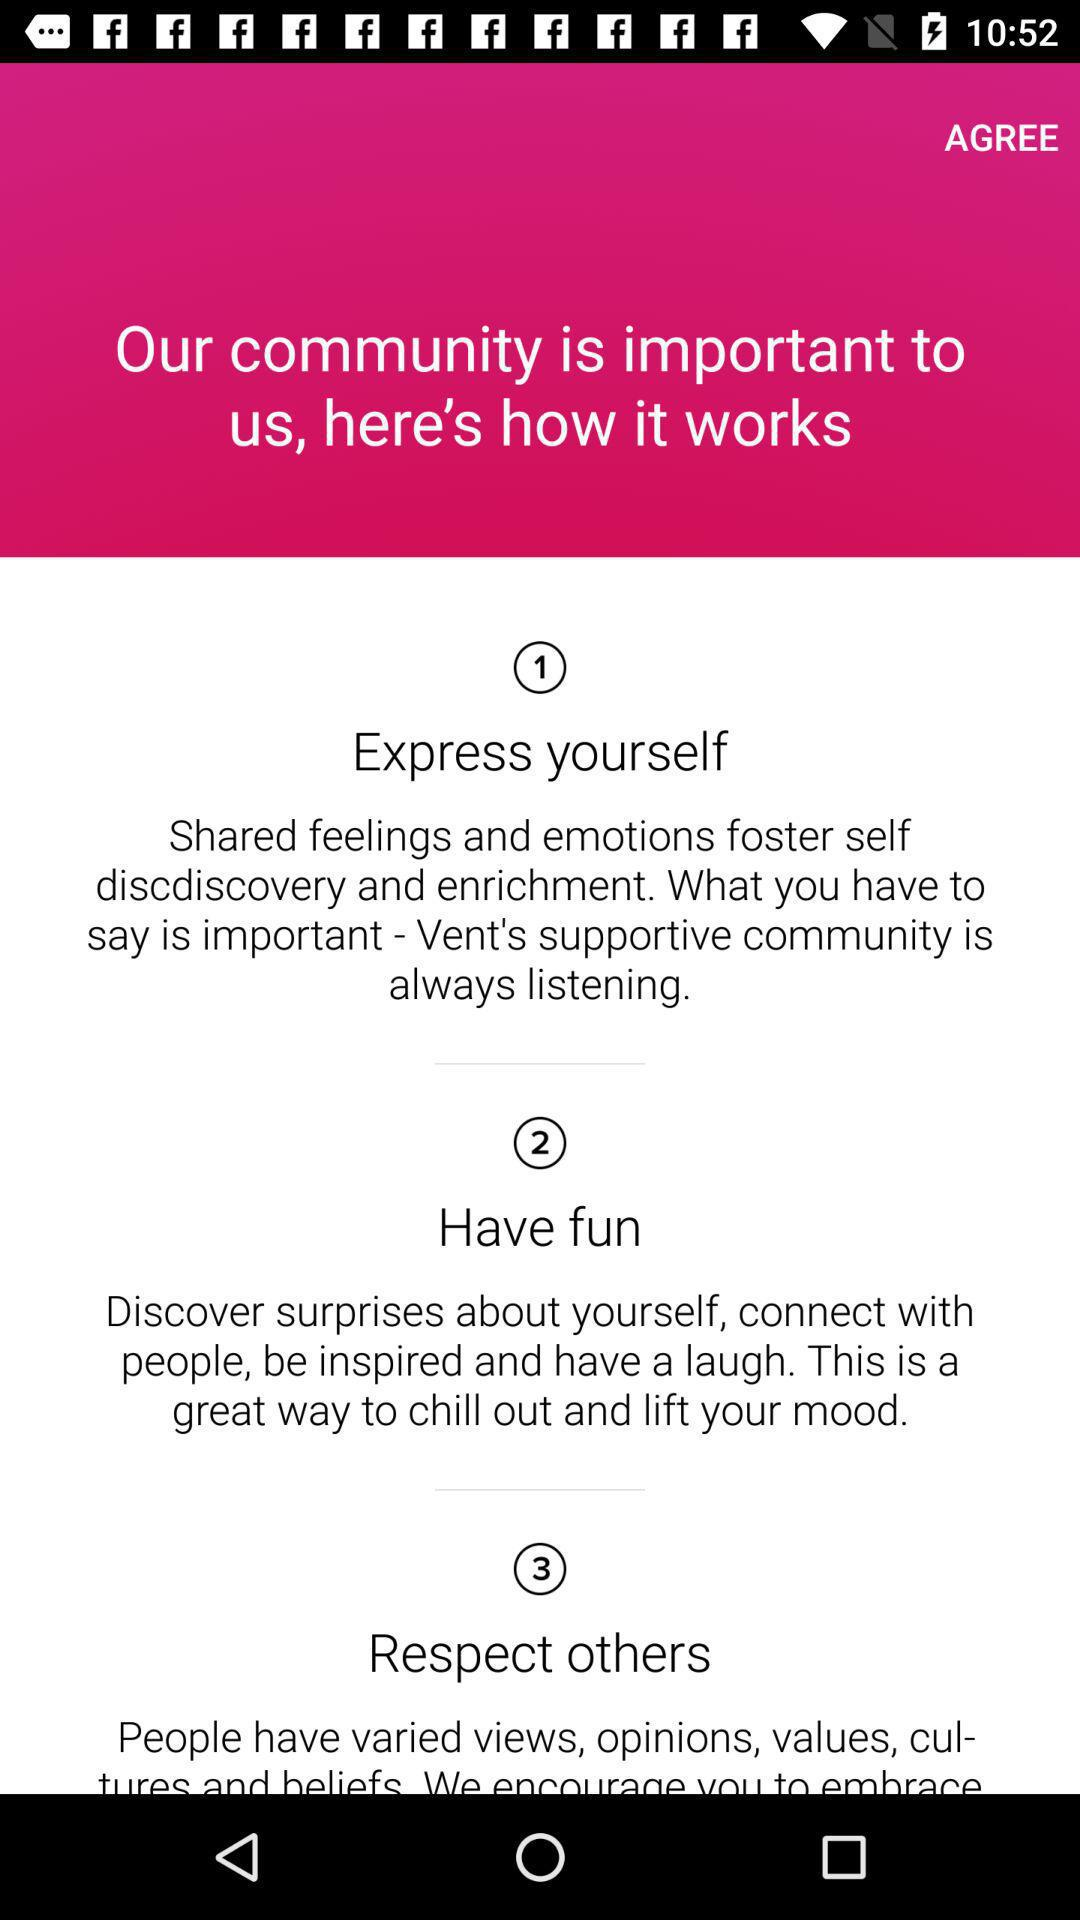What are the points? The points are "Express yourself :Shared feelings and emotions foster self discdiscovery and enrichment. What you have to say is important- Vent's supportive community is always listening", "Have fun: Discover surprises about yourself, connect with people, be inspired and have a laugh. This is a great way to chill out and lift your mood", and "Respect others: People have varied views, opinions, values, cultures and beliefs. We encourage you to embrace". 